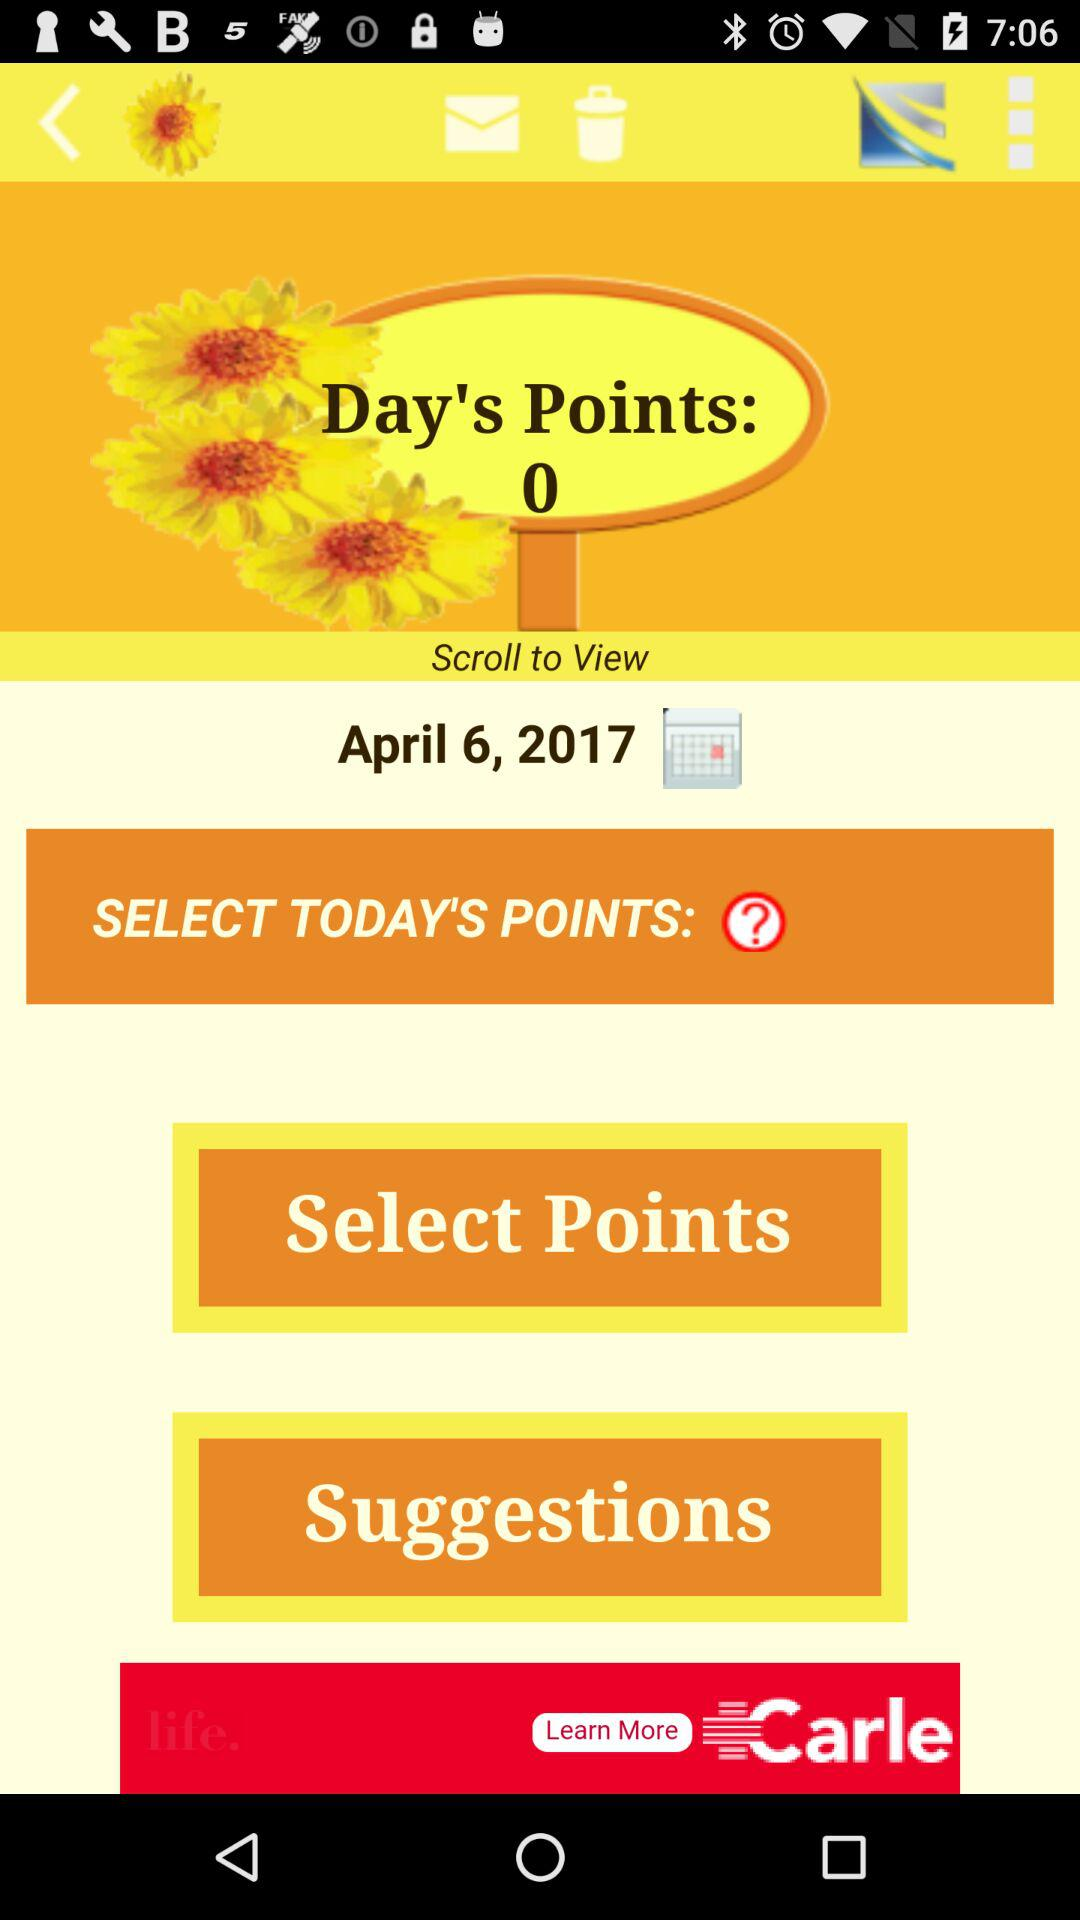Which day of the week falls on April 6, 2017?
When the provided information is insufficient, respond with <no answer>. <no answer> 